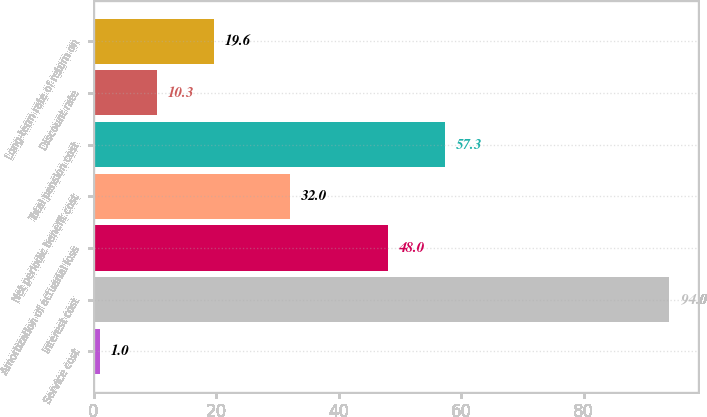Convert chart. <chart><loc_0><loc_0><loc_500><loc_500><bar_chart><fcel>Service cost<fcel>Interest cost<fcel>Amortization of actuarial loss<fcel>Net periodic benefit cost<fcel>Total pension cost<fcel>Discount rate<fcel>Long-term rate of return on<nl><fcel>1<fcel>94<fcel>48<fcel>32<fcel>57.3<fcel>10.3<fcel>19.6<nl></chart> 